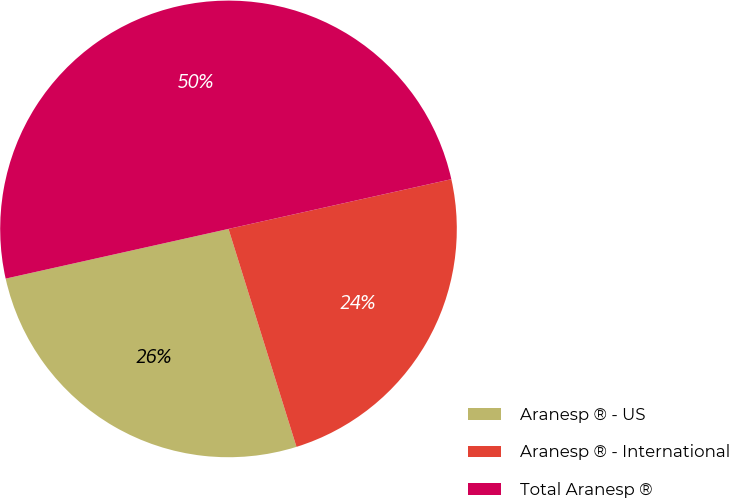Convert chart. <chart><loc_0><loc_0><loc_500><loc_500><pie_chart><fcel>Aranesp ® - US<fcel>Aranesp ® - International<fcel>Total Aranesp ®<nl><fcel>26.32%<fcel>23.68%<fcel>50.0%<nl></chart> 